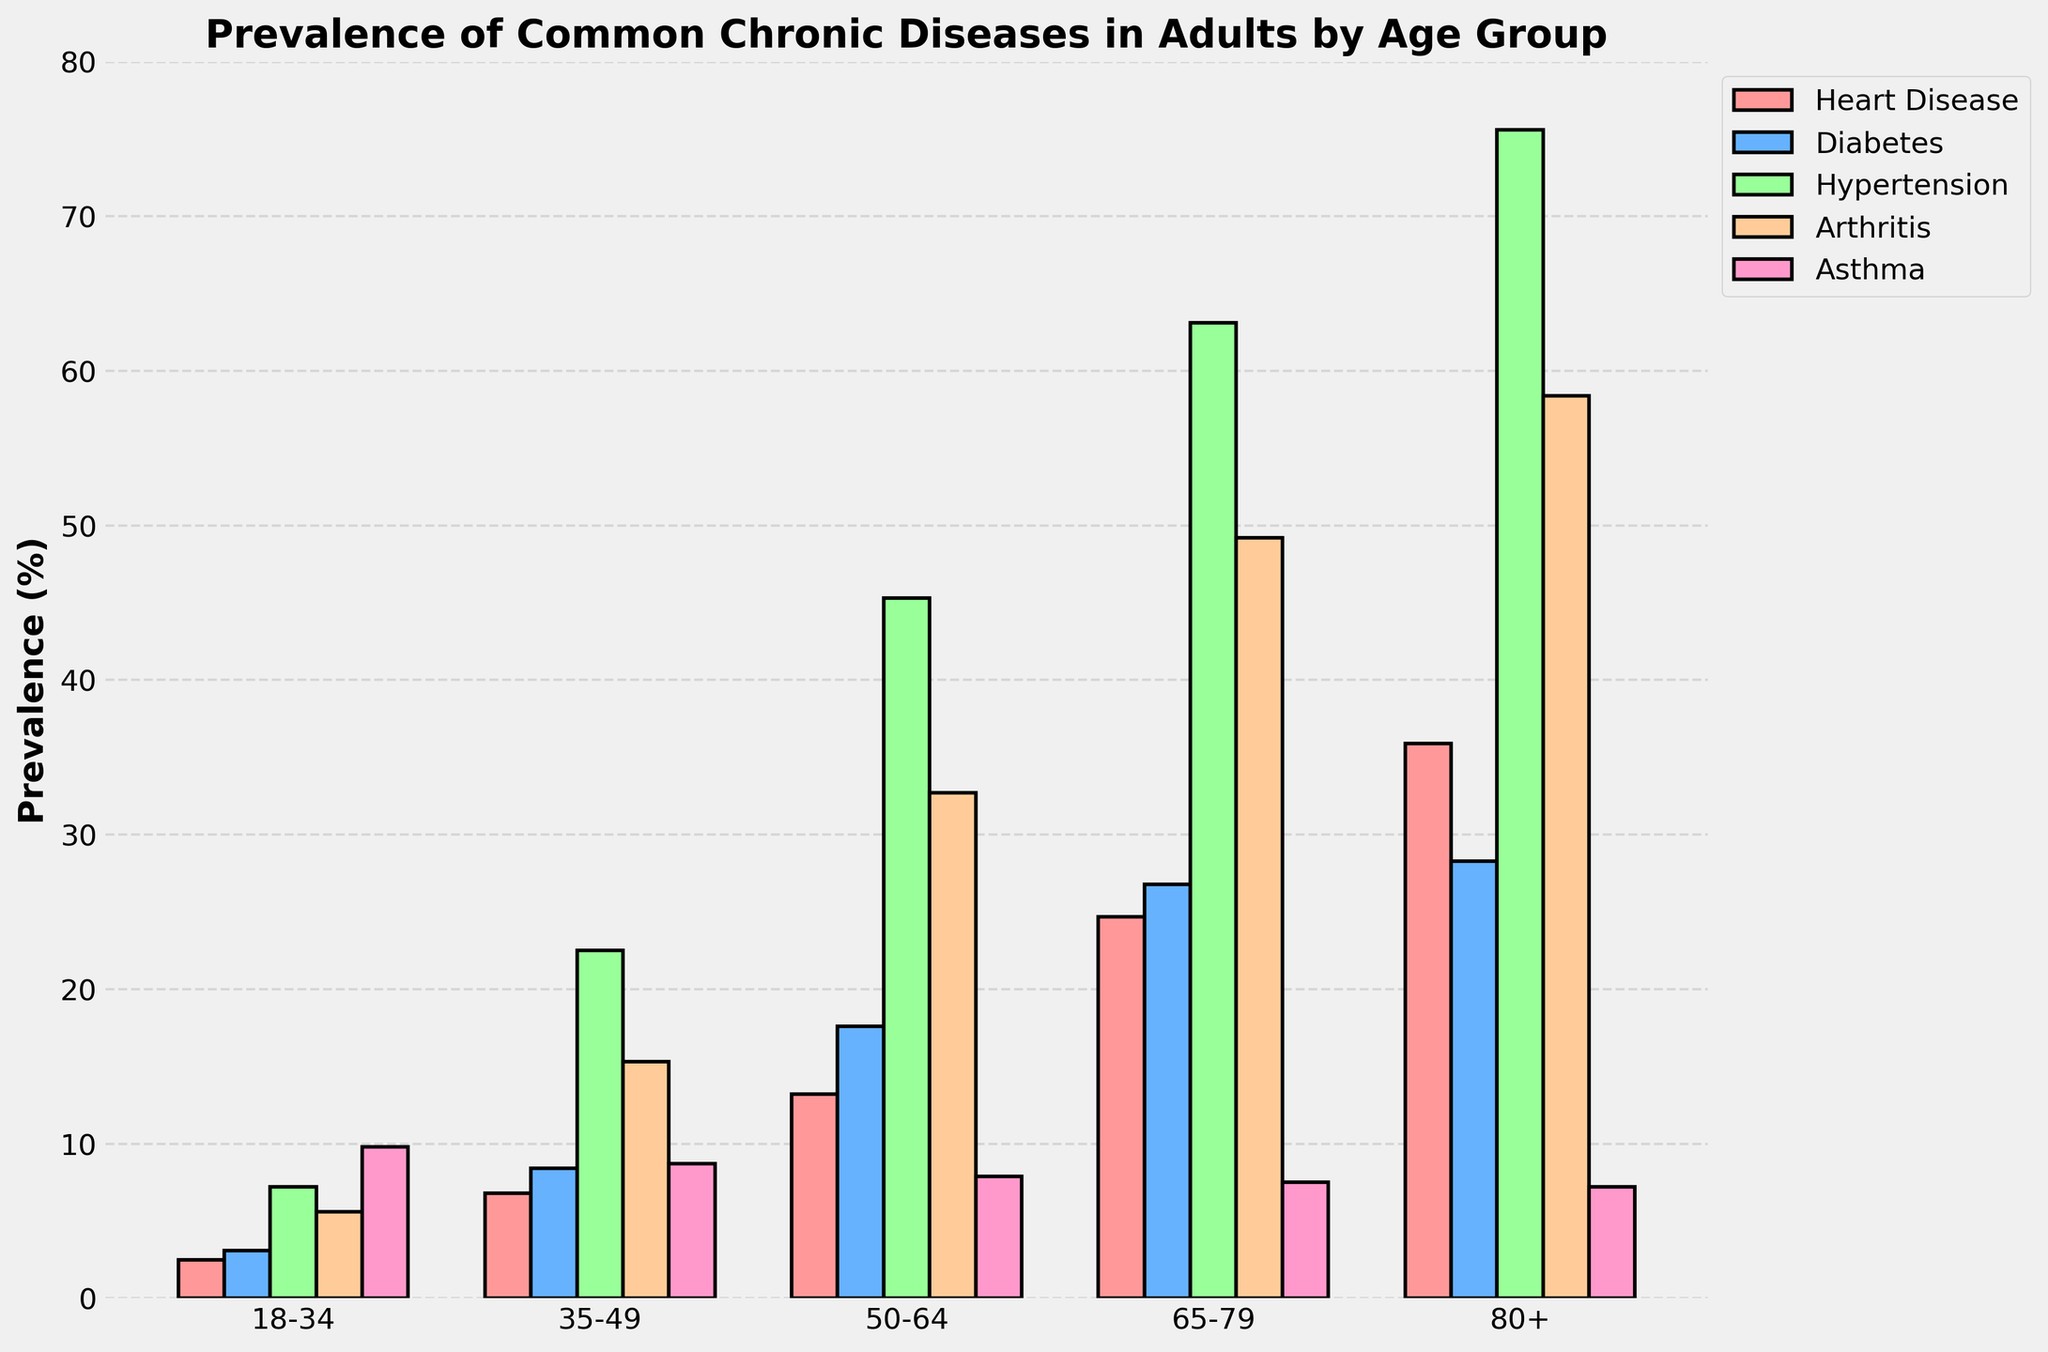What is the age group with the highest prevalence of heart disease? By visually examining the heights of the bars representing heart disease, we can see that the 80+ age group has the tallest bar. Therefore, this age group has the highest prevalence of heart disease.
Answer: 80+ Which disease is least prevalent in the 35-49 age group? In the bar cluster for the 35-49 age group, the bar representing asthma is the shortest. Therefore, asthma is the least prevalent disease in this age group.
Answer: Asthma Compare the prevalence of diabetes between the 50-64 and the 65-79 age groups. Which age group has a higher prevalence and by how much? The bar for diabetes in the 65-79 age group is taller than the one for the 50-64 age group. The prevalence in 65-79 is 26.8% and in 50-64 is 17.6%. Subtracting the two gives the difference: 26.8 - 17.6 = 9.2.
Answer: 65-79 by 9.2% Which disease shows a decreasing trend in prevalence as age increases from 18-34 to 80+? By examining the heights of the bars for each disease across the age groups, asthma shows a decreasing trend, as the bars continuously become shorter from the 18-34 age group to the 80+ age group.
Answer: Asthma Calculate the average prevalence of hypertension across all age groups. The prevalence of hypertension in each age group are 7.2, 22.5, 45.3, 63.1, and 75.6. Summing these values gives 213.7. Dividing by the number of age groups (5) gives the average: 213.7 / 5 = 42.74.
Answer: 42.74 What is the sum of the prevalence rates for all the diseases in the 50-64 age group? The prevalence rates for the diseases in the 50-64 age group are 13.2, 17.6, 45.3, 32.7, and 7.9. Summing these values gives: 13.2 + 17.6 + 45.3 + 32.7 + 7.9 = 116.7.
Answer: 116.7 Which age group shows the highest prevalence of arthritis? The tallest bar representing arthritis is seen in the 80+ age group. Therefore, this age group has the highest prevalence of arthritis.
Answer: 80+ Compare the prevalence of asthma between the youngest (18-34) and the oldest (80+) age groups. Which one has a higher prevalence and by how much? The prevalence of asthma in the 18-34 age group is 9.8%, while in the 80+ age group it is 7.2%. Subtracting these gives the difference: 9.8 - 7.2 = 2.6.
Answer: 18-34 by 2.6% 